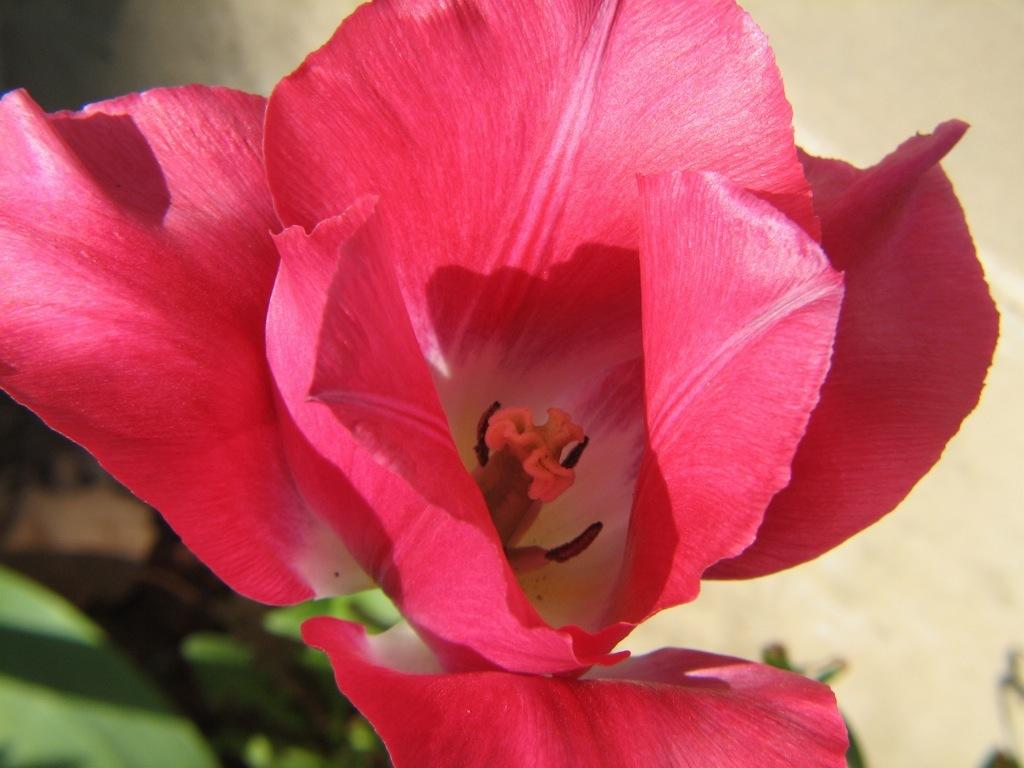What is the main subject in the foreground of the image? There is a flower in the foreground of the image. What can be seen in the background of the image? There is a wall and plants in the background of the image. What type of skirt can be seen in the image? There is no skirt present in the image; it features a flower in the foreground and a wall and plants in the background. 